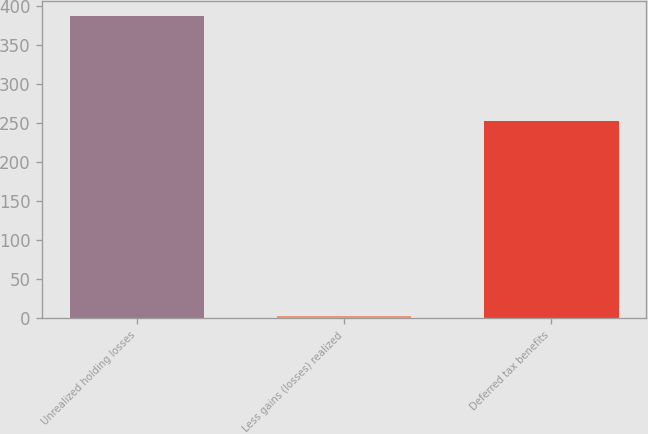<chart> <loc_0><loc_0><loc_500><loc_500><bar_chart><fcel>Unrealized holding losses<fcel>Less gains (losses) realized<fcel>Deferred tax benefits<nl><fcel>387<fcel>3<fcel>253<nl></chart> 